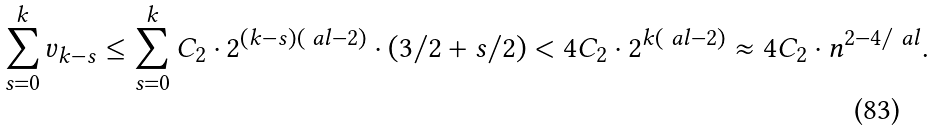Convert formula to latex. <formula><loc_0><loc_0><loc_500><loc_500>\sum _ { s = 0 } ^ { k } v _ { k - s } \leq \sum _ { s = 0 } ^ { k } C _ { 2 } \cdot 2 ^ { ( k - s ) ( \ a l - 2 ) } \cdot ( 3 / 2 + s / 2 ) < 4 C _ { 2 } \cdot 2 ^ { k ( \ a l - 2 ) } \approx 4 C _ { 2 } \cdot n ^ { 2 - 4 / \ a l } .</formula> 